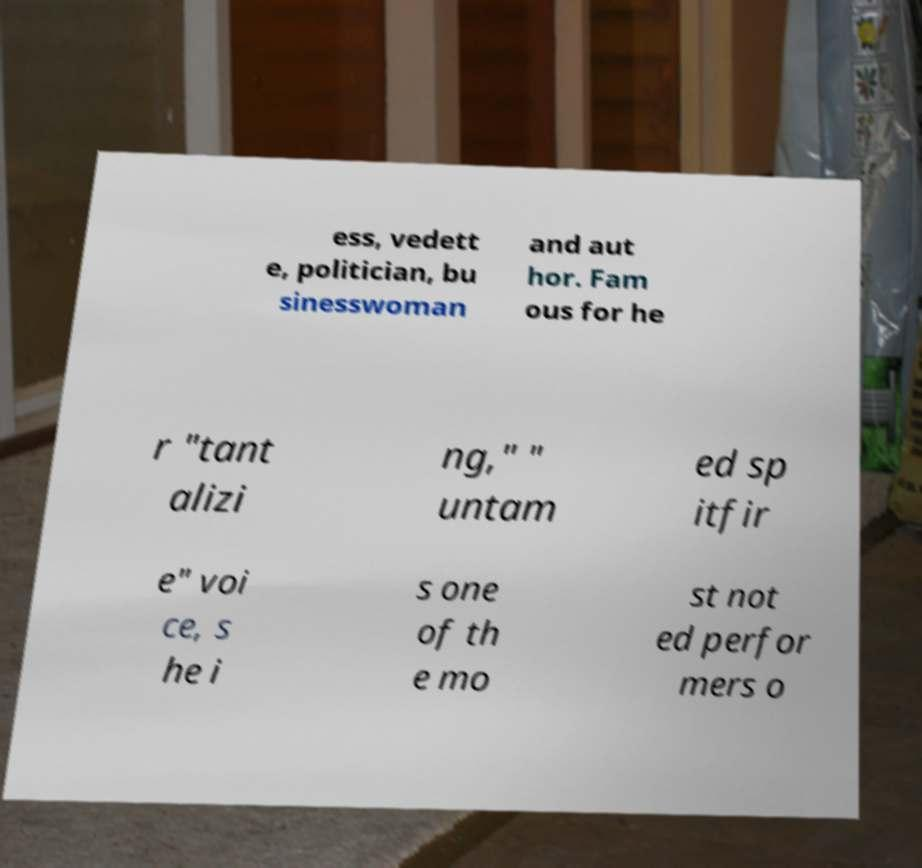Please identify and transcribe the text found in this image. ess, vedett e, politician, bu sinesswoman and aut hor. Fam ous for he r "tant alizi ng," " untam ed sp itfir e" voi ce, s he i s one of th e mo st not ed perfor mers o 